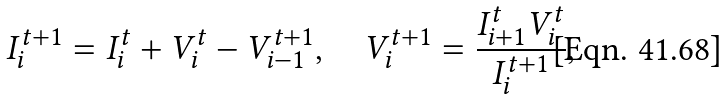Convert formula to latex. <formula><loc_0><loc_0><loc_500><loc_500>I _ { i } ^ { t + 1 } = I _ { i } ^ { t } + V _ { i } ^ { t } - V _ { i - 1 } ^ { t + 1 } , \quad V _ { i } ^ { t + 1 } = \frac { I _ { i + 1 } ^ { t } V _ { i } ^ { t } } { I _ { i } ^ { t + 1 } } ,</formula> 